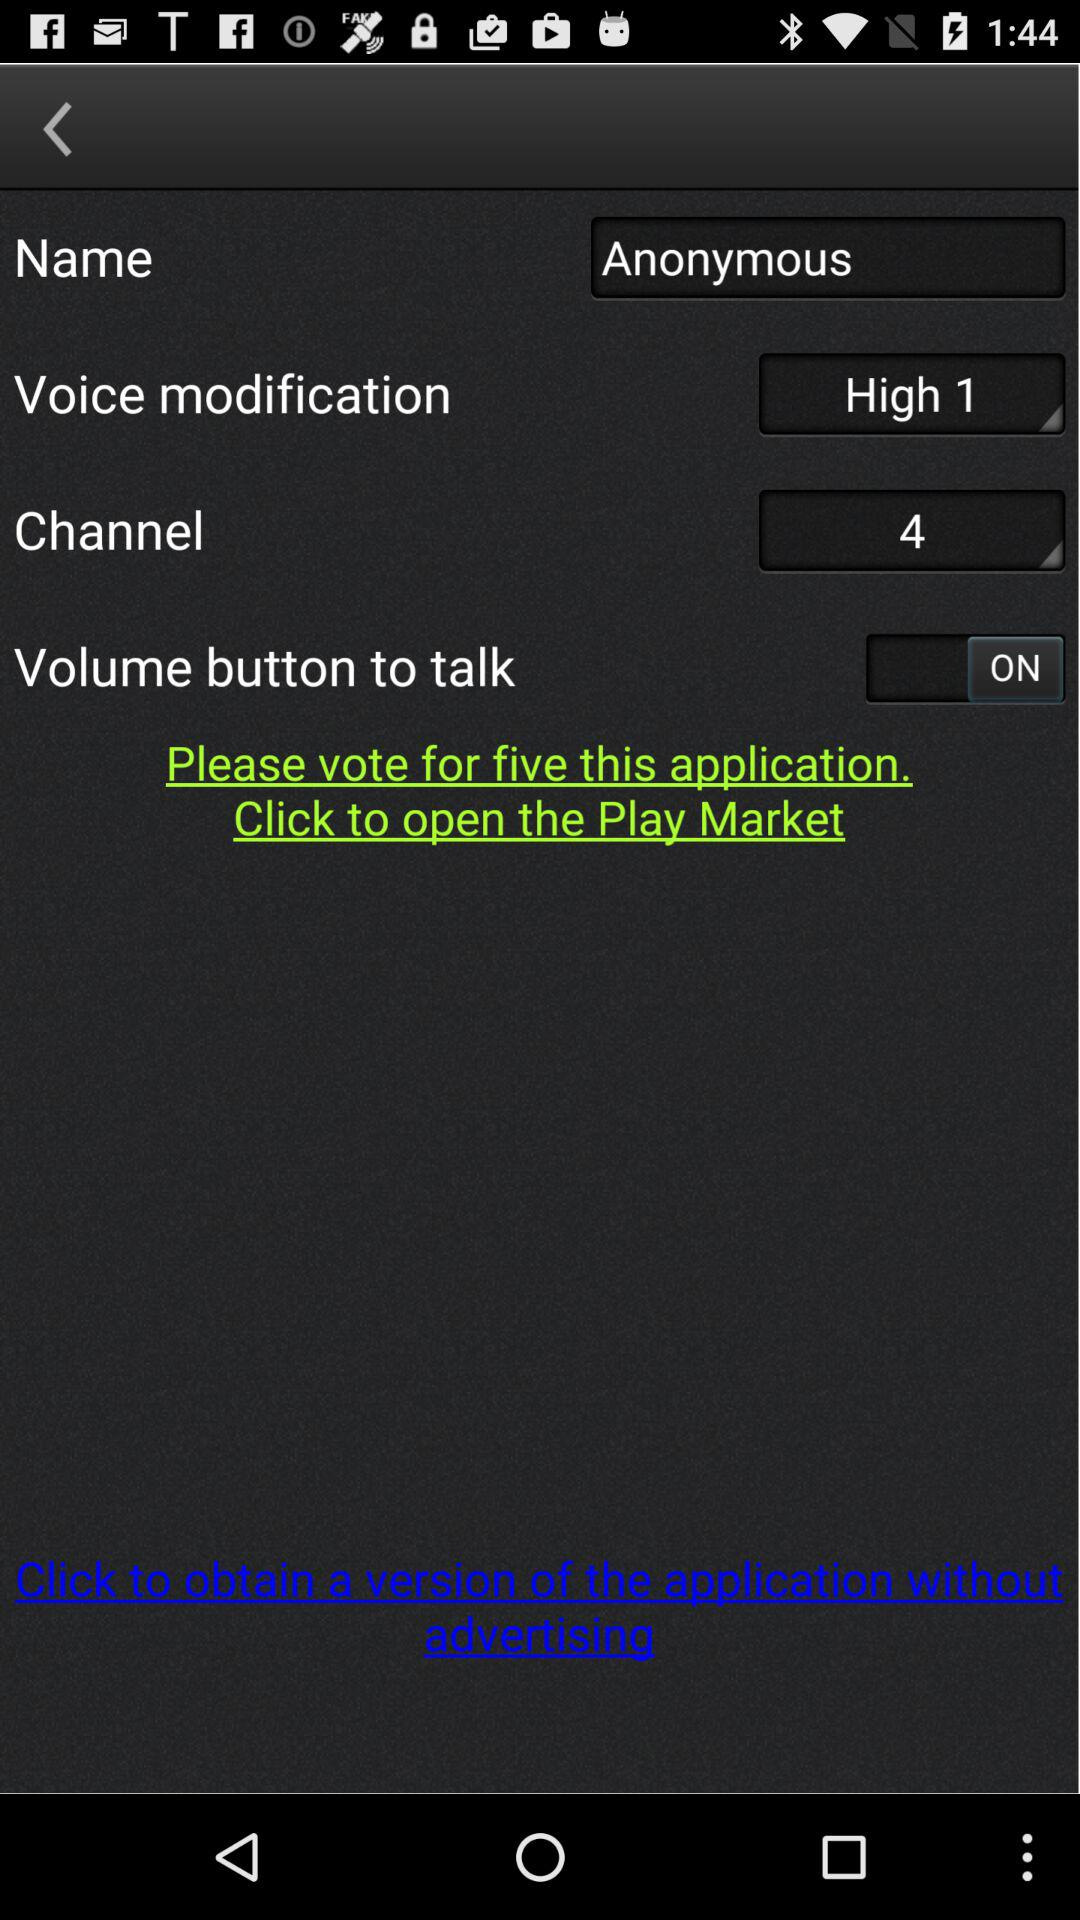What's the status of the "Volume button to talk"? The status is on. 